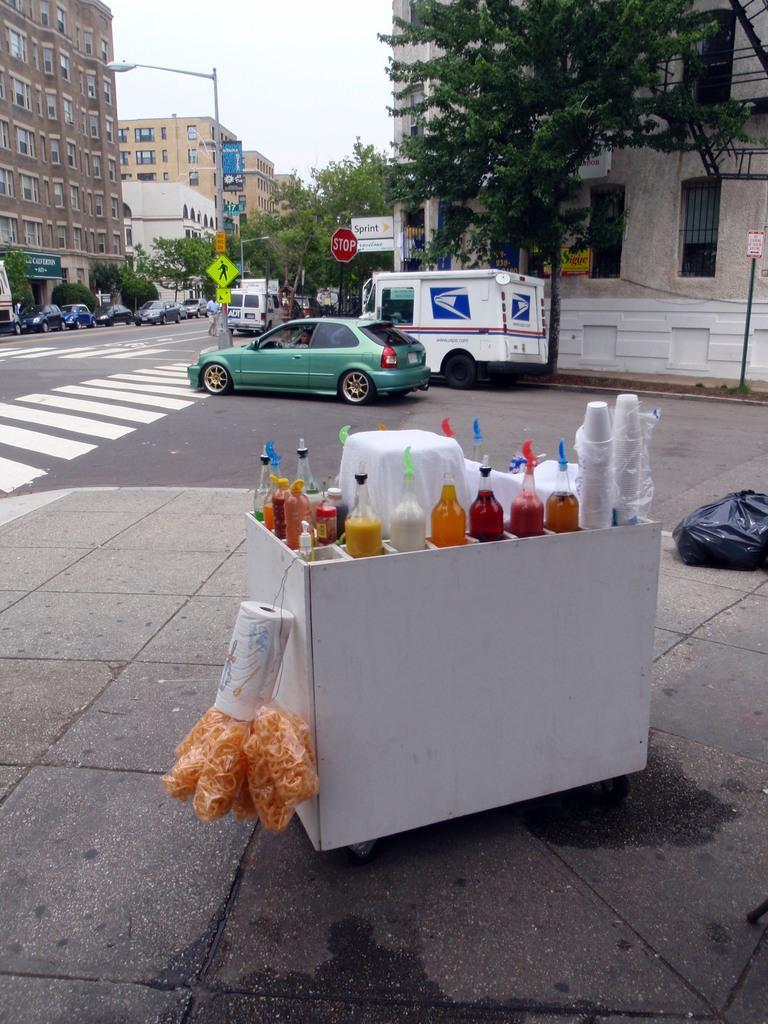In one or two sentences, can you explain what this image depicts? In this image I see a box on which there are bottles and I see cups and I see the roll of white paper and food in these covers and I see the path and I see a black cover over here. In the background I see the buildings, a pole on which there are few boards, vehicles, road and I see the trees and the sky. 